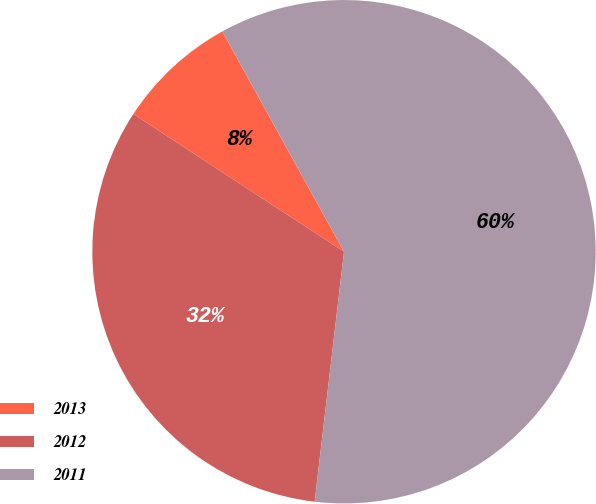Convert chart. <chart><loc_0><loc_0><loc_500><loc_500><pie_chart><fcel>2013<fcel>2012<fcel>2011<nl><fcel>7.75%<fcel>32.35%<fcel>59.89%<nl></chart> 